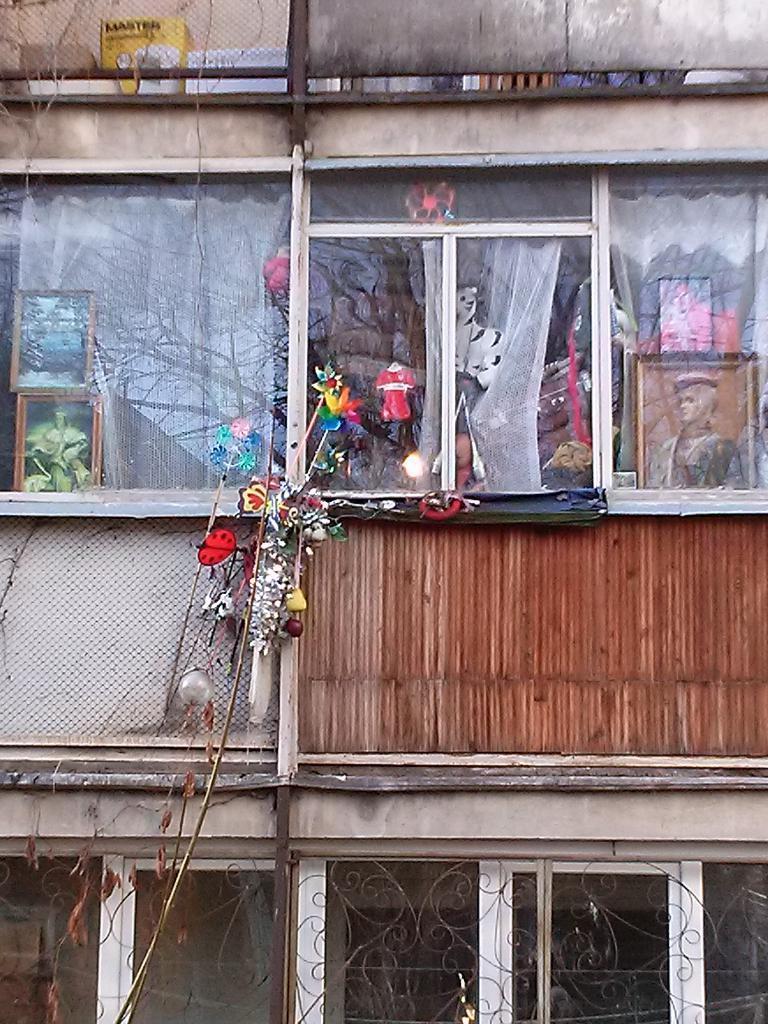In one or two sentences, can you explain what this image depicts? This image consists of a building along with windows. The windows are made up of glasses. 